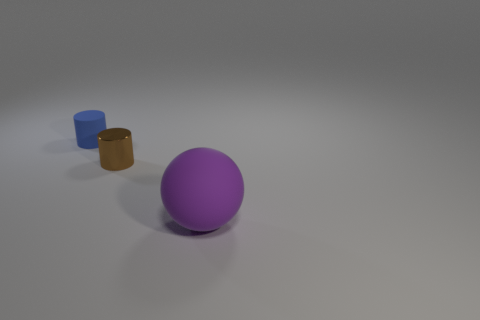Add 1 large cyan shiny balls. How many objects exist? 4 Subtract all cylinders. How many objects are left? 1 Add 3 tiny rubber objects. How many tiny rubber objects exist? 4 Subtract 0 red balls. How many objects are left? 3 Subtract all purple matte spheres. Subtract all brown objects. How many objects are left? 1 Add 1 large purple matte objects. How many large purple matte objects are left? 2 